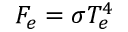Convert formula to latex. <formula><loc_0><loc_0><loc_500><loc_500>F _ { e } = \sigma T _ { e } ^ { 4 }</formula> 